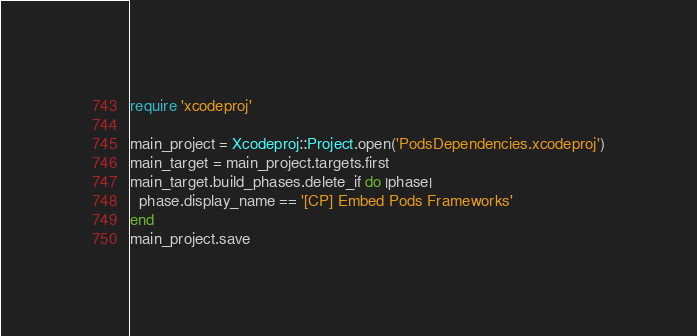Convert code to text. <code><loc_0><loc_0><loc_500><loc_500><_Ruby_>require 'xcodeproj'

main_project = Xcodeproj::Project.open('PodsDependencies.xcodeproj')
main_target = main_project.targets.first
main_target.build_phases.delete_if do |phase|
  phase.display_name == '[CP] Embed Pods Frameworks'
end
main_project.save
</code> 